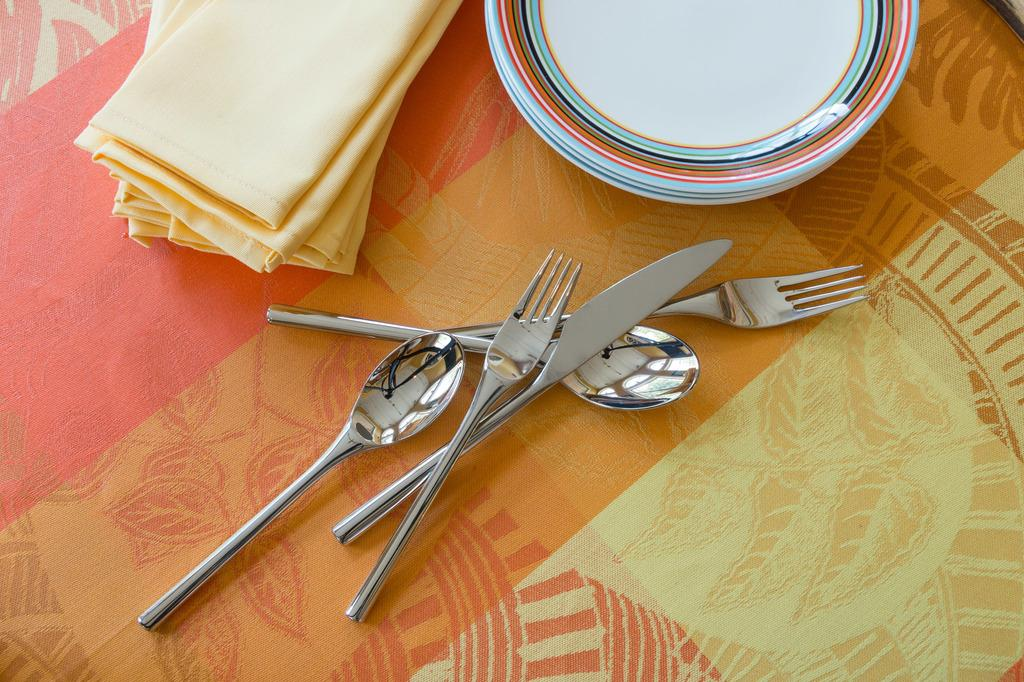What is on the table in the image? There is a plate, spoons, a knife, a fork, and a napkin on the table. Can you describe the utensils present on the table? Yes, there are spoons, a knife, and a fork on the table. What might be used for cleaning or wiping in the image? A napkin is present on the table for cleaning or wiping. What type of police officer is present in the image? There is no police officer present in the image; it features a table with various items on it. What role does the glue play in the image? There is no glue present in the image. Who is the manager of the establishment in the image? There is no establishment or manager present in the image. 